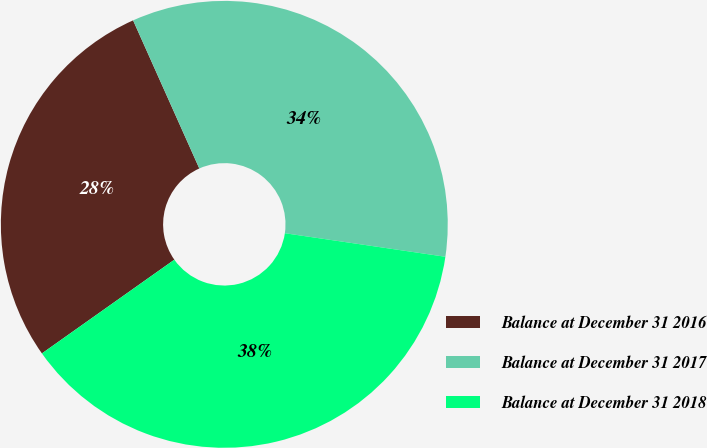Convert chart. <chart><loc_0><loc_0><loc_500><loc_500><pie_chart><fcel>Balance at December 31 2016<fcel>Balance at December 31 2017<fcel>Balance at December 31 2018<nl><fcel>28.11%<fcel>34.01%<fcel>37.88%<nl></chart> 